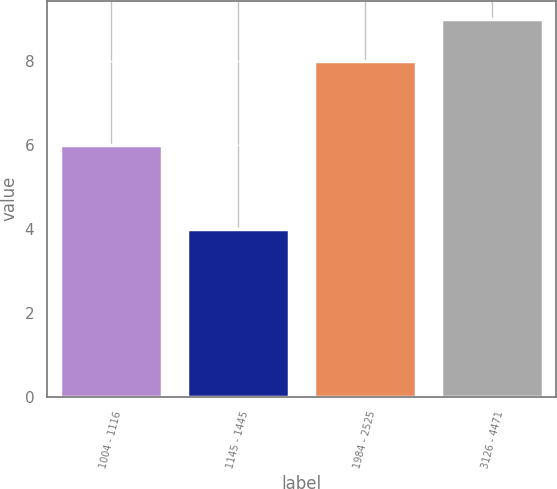Convert chart to OTSL. <chart><loc_0><loc_0><loc_500><loc_500><bar_chart><fcel>1004 - 1116<fcel>1145 - 1445<fcel>1984 - 2525<fcel>3126 - 4471<nl><fcel>6<fcel>4<fcel>8<fcel>9<nl></chart> 